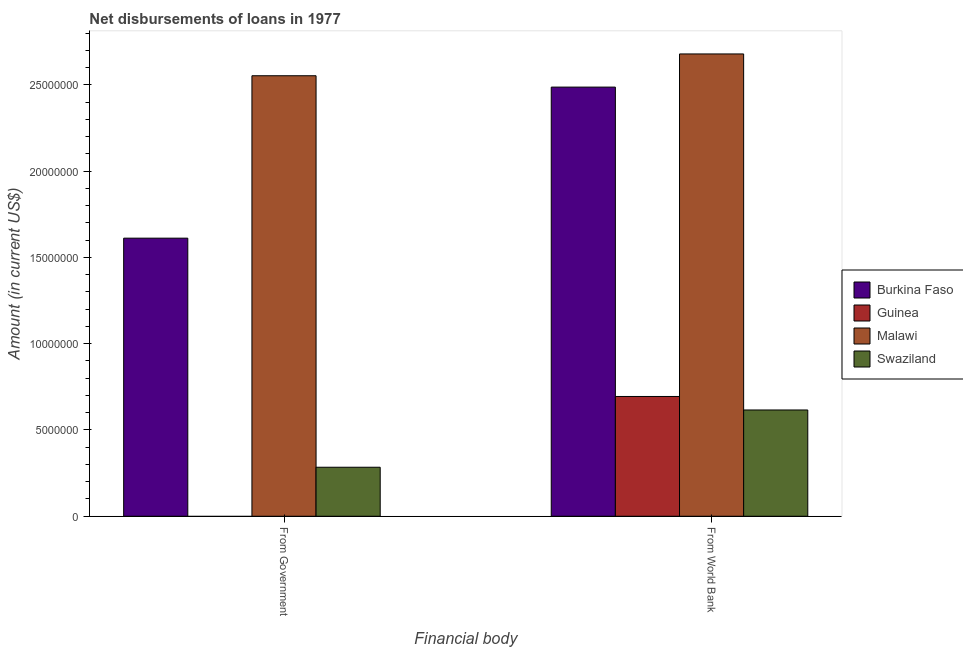How many different coloured bars are there?
Provide a succinct answer. 4. How many groups of bars are there?
Ensure brevity in your answer.  2. How many bars are there on the 2nd tick from the left?
Ensure brevity in your answer.  4. What is the label of the 1st group of bars from the left?
Make the answer very short. From Government. What is the net disbursements of loan from world bank in Burkina Faso?
Provide a succinct answer. 2.49e+07. Across all countries, what is the maximum net disbursements of loan from government?
Make the answer very short. 2.55e+07. Across all countries, what is the minimum net disbursements of loan from world bank?
Your response must be concise. 6.16e+06. In which country was the net disbursements of loan from government maximum?
Your response must be concise. Malawi. What is the total net disbursements of loan from world bank in the graph?
Give a very brief answer. 6.48e+07. What is the difference between the net disbursements of loan from world bank in Guinea and that in Burkina Faso?
Your answer should be very brief. -1.79e+07. What is the difference between the net disbursements of loan from world bank in Swaziland and the net disbursements of loan from government in Malawi?
Offer a terse response. -1.94e+07. What is the average net disbursements of loan from world bank per country?
Provide a short and direct response. 1.62e+07. What is the difference between the net disbursements of loan from world bank and net disbursements of loan from government in Swaziland?
Ensure brevity in your answer.  3.32e+06. What is the ratio of the net disbursements of loan from government in Burkina Faso to that in Swaziland?
Your answer should be very brief. 5.67. Are all the bars in the graph horizontal?
Your answer should be compact. No. Are the values on the major ticks of Y-axis written in scientific E-notation?
Provide a succinct answer. No. Does the graph contain any zero values?
Your response must be concise. Yes. How many legend labels are there?
Keep it short and to the point. 4. How are the legend labels stacked?
Your response must be concise. Vertical. What is the title of the graph?
Keep it short and to the point. Net disbursements of loans in 1977. Does "Marshall Islands" appear as one of the legend labels in the graph?
Ensure brevity in your answer.  No. What is the label or title of the X-axis?
Your response must be concise. Financial body. What is the Amount (in current US$) of Burkina Faso in From Government?
Provide a succinct answer. 1.61e+07. What is the Amount (in current US$) in Guinea in From Government?
Your answer should be compact. 0. What is the Amount (in current US$) in Malawi in From Government?
Provide a short and direct response. 2.55e+07. What is the Amount (in current US$) in Swaziland in From Government?
Ensure brevity in your answer.  2.84e+06. What is the Amount (in current US$) of Burkina Faso in From World Bank?
Keep it short and to the point. 2.49e+07. What is the Amount (in current US$) in Guinea in From World Bank?
Your answer should be very brief. 6.94e+06. What is the Amount (in current US$) of Malawi in From World Bank?
Give a very brief answer. 2.68e+07. What is the Amount (in current US$) of Swaziland in From World Bank?
Provide a short and direct response. 6.16e+06. Across all Financial body, what is the maximum Amount (in current US$) of Burkina Faso?
Your answer should be compact. 2.49e+07. Across all Financial body, what is the maximum Amount (in current US$) in Guinea?
Your answer should be compact. 6.94e+06. Across all Financial body, what is the maximum Amount (in current US$) of Malawi?
Offer a very short reply. 2.68e+07. Across all Financial body, what is the maximum Amount (in current US$) in Swaziland?
Keep it short and to the point. 6.16e+06. Across all Financial body, what is the minimum Amount (in current US$) of Burkina Faso?
Your answer should be very brief. 1.61e+07. Across all Financial body, what is the minimum Amount (in current US$) in Malawi?
Your answer should be very brief. 2.55e+07. Across all Financial body, what is the minimum Amount (in current US$) of Swaziland?
Offer a terse response. 2.84e+06. What is the total Amount (in current US$) of Burkina Faso in the graph?
Ensure brevity in your answer.  4.10e+07. What is the total Amount (in current US$) in Guinea in the graph?
Offer a very short reply. 6.94e+06. What is the total Amount (in current US$) of Malawi in the graph?
Give a very brief answer. 5.23e+07. What is the total Amount (in current US$) in Swaziland in the graph?
Offer a terse response. 9.00e+06. What is the difference between the Amount (in current US$) in Burkina Faso in From Government and that in From World Bank?
Your answer should be very brief. -8.76e+06. What is the difference between the Amount (in current US$) in Malawi in From Government and that in From World Bank?
Give a very brief answer. -1.26e+06. What is the difference between the Amount (in current US$) in Swaziland in From Government and that in From World Bank?
Offer a very short reply. -3.32e+06. What is the difference between the Amount (in current US$) in Burkina Faso in From Government and the Amount (in current US$) in Guinea in From World Bank?
Your response must be concise. 9.18e+06. What is the difference between the Amount (in current US$) of Burkina Faso in From Government and the Amount (in current US$) of Malawi in From World Bank?
Your answer should be very brief. -1.07e+07. What is the difference between the Amount (in current US$) in Burkina Faso in From Government and the Amount (in current US$) in Swaziland in From World Bank?
Provide a short and direct response. 9.96e+06. What is the difference between the Amount (in current US$) in Malawi in From Government and the Amount (in current US$) in Swaziland in From World Bank?
Your answer should be very brief. 1.94e+07. What is the average Amount (in current US$) of Burkina Faso per Financial body?
Offer a very short reply. 2.05e+07. What is the average Amount (in current US$) in Guinea per Financial body?
Offer a terse response. 3.47e+06. What is the average Amount (in current US$) in Malawi per Financial body?
Your response must be concise. 2.62e+07. What is the average Amount (in current US$) in Swaziland per Financial body?
Provide a succinct answer. 4.50e+06. What is the difference between the Amount (in current US$) of Burkina Faso and Amount (in current US$) of Malawi in From Government?
Ensure brevity in your answer.  -9.41e+06. What is the difference between the Amount (in current US$) of Burkina Faso and Amount (in current US$) of Swaziland in From Government?
Offer a very short reply. 1.33e+07. What is the difference between the Amount (in current US$) in Malawi and Amount (in current US$) in Swaziland in From Government?
Your answer should be compact. 2.27e+07. What is the difference between the Amount (in current US$) of Burkina Faso and Amount (in current US$) of Guinea in From World Bank?
Your response must be concise. 1.79e+07. What is the difference between the Amount (in current US$) in Burkina Faso and Amount (in current US$) in Malawi in From World Bank?
Keep it short and to the point. -1.92e+06. What is the difference between the Amount (in current US$) of Burkina Faso and Amount (in current US$) of Swaziland in From World Bank?
Offer a very short reply. 1.87e+07. What is the difference between the Amount (in current US$) in Guinea and Amount (in current US$) in Malawi in From World Bank?
Your answer should be very brief. -1.99e+07. What is the difference between the Amount (in current US$) of Guinea and Amount (in current US$) of Swaziland in From World Bank?
Offer a terse response. 7.82e+05. What is the difference between the Amount (in current US$) of Malawi and Amount (in current US$) of Swaziland in From World Bank?
Offer a very short reply. 2.06e+07. What is the ratio of the Amount (in current US$) of Burkina Faso in From Government to that in From World Bank?
Your answer should be very brief. 0.65. What is the ratio of the Amount (in current US$) of Malawi in From Government to that in From World Bank?
Give a very brief answer. 0.95. What is the ratio of the Amount (in current US$) of Swaziland in From Government to that in From World Bank?
Offer a terse response. 0.46. What is the difference between the highest and the second highest Amount (in current US$) of Burkina Faso?
Offer a very short reply. 8.76e+06. What is the difference between the highest and the second highest Amount (in current US$) in Malawi?
Your answer should be compact. 1.26e+06. What is the difference between the highest and the second highest Amount (in current US$) of Swaziland?
Ensure brevity in your answer.  3.32e+06. What is the difference between the highest and the lowest Amount (in current US$) of Burkina Faso?
Your answer should be very brief. 8.76e+06. What is the difference between the highest and the lowest Amount (in current US$) of Guinea?
Provide a succinct answer. 6.94e+06. What is the difference between the highest and the lowest Amount (in current US$) in Malawi?
Offer a terse response. 1.26e+06. What is the difference between the highest and the lowest Amount (in current US$) in Swaziland?
Your response must be concise. 3.32e+06. 